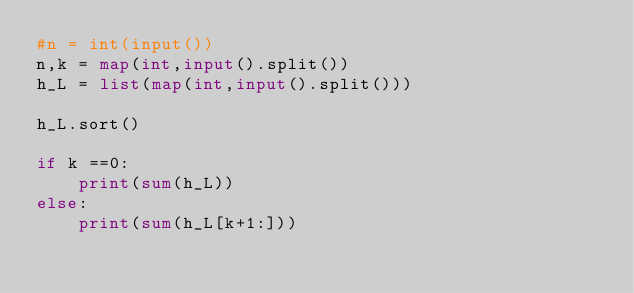<code> <loc_0><loc_0><loc_500><loc_500><_Python_>#n = int(input())
n,k = map(int,input().split())
h_L = list(map(int,input().split()))

h_L.sort()

if k ==0:
    print(sum(h_L))
else:
    print(sum(h_L[k+1:]))</code> 